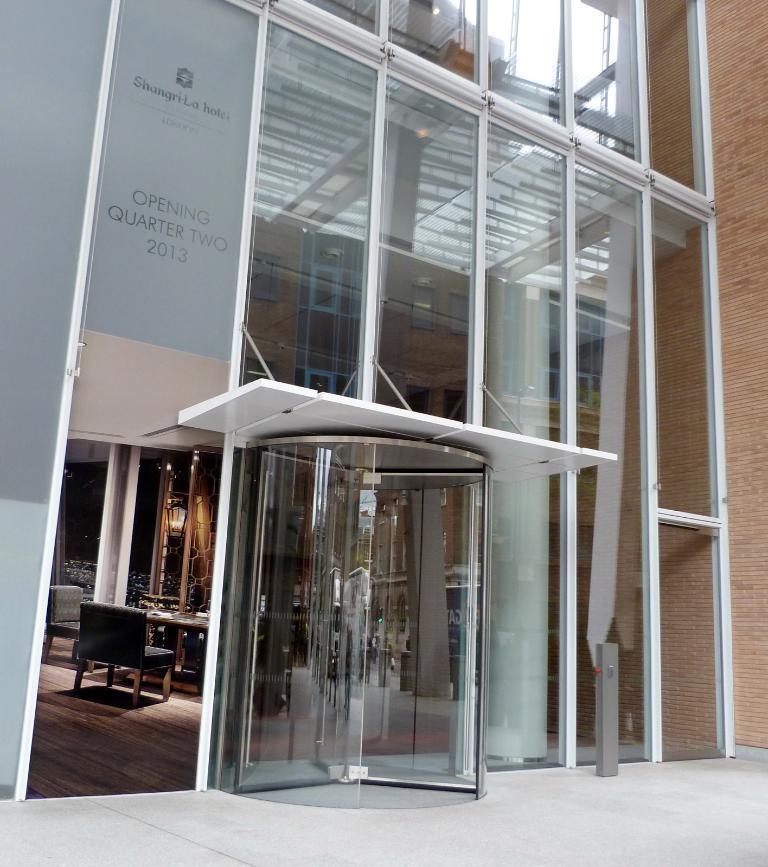Describe this image in one or two sentences. In this image we can see a building with glasses. Inside the building there is a table and chairs. 